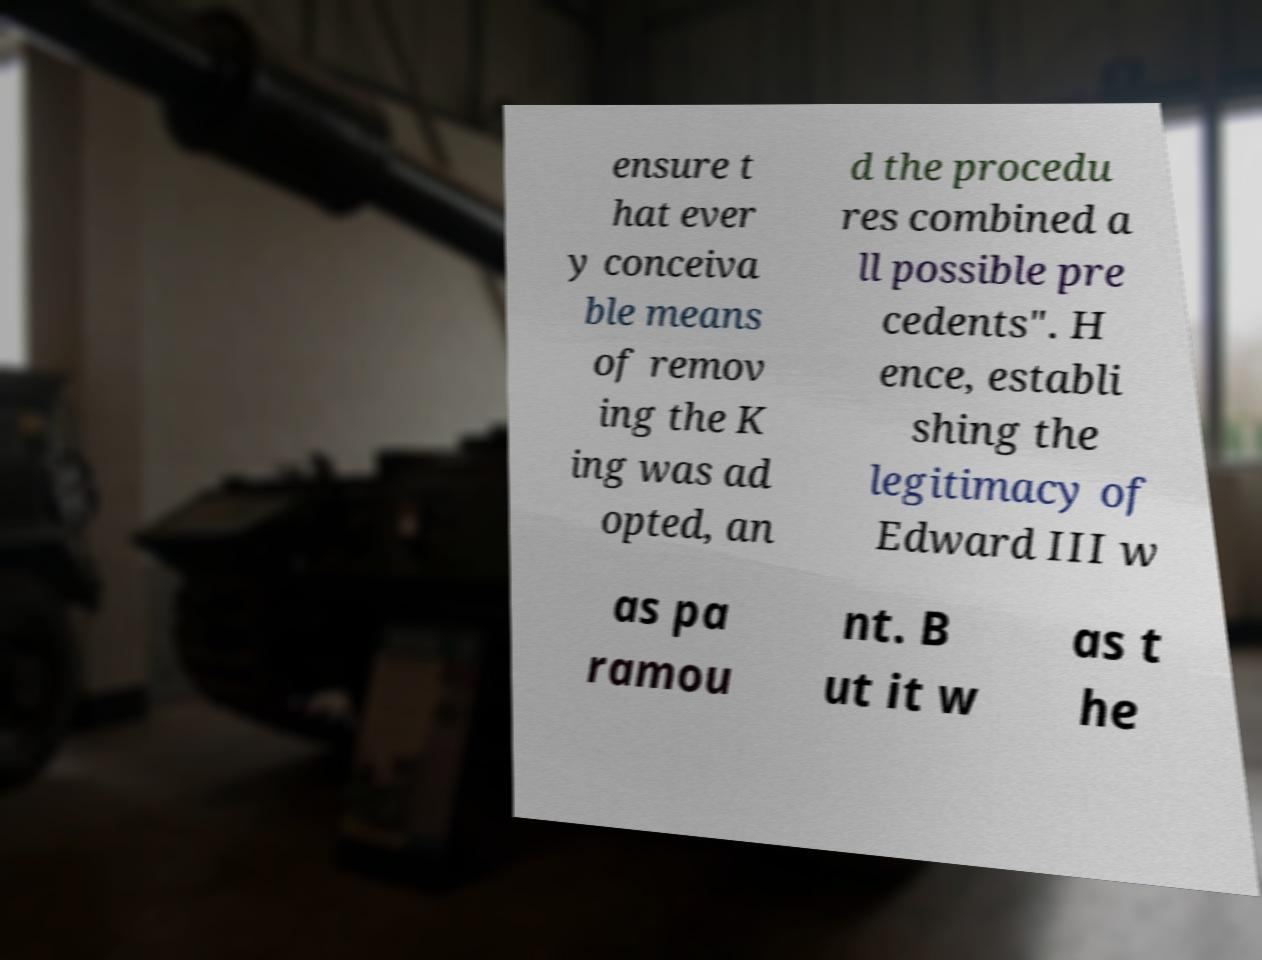I need the written content from this picture converted into text. Can you do that? ensure t hat ever y conceiva ble means of remov ing the K ing was ad opted, an d the procedu res combined a ll possible pre cedents". H ence, establi shing the legitimacy of Edward III w as pa ramou nt. B ut it w as t he 